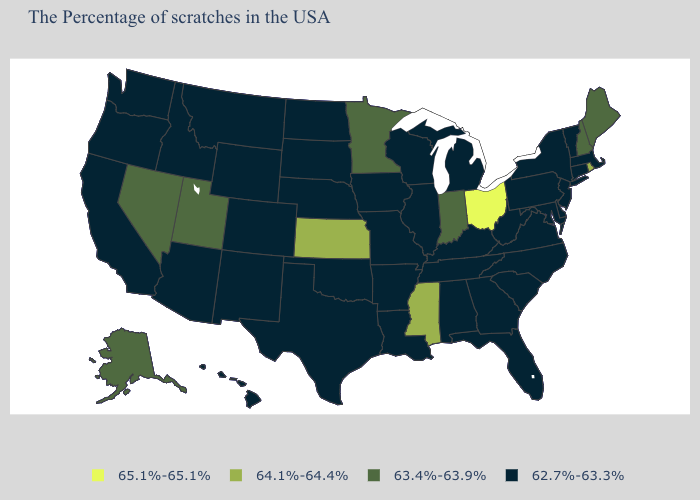Name the states that have a value in the range 64.1%-64.4%?
Give a very brief answer. Rhode Island, Mississippi, Kansas. What is the value of Minnesota?
Quick response, please. 63.4%-63.9%. What is the value of New Jersey?
Keep it brief. 62.7%-63.3%. What is the highest value in states that border Wisconsin?
Short answer required. 63.4%-63.9%. Name the states that have a value in the range 64.1%-64.4%?
Give a very brief answer. Rhode Island, Mississippi, Kansas. Name the states that have a value in the range 63.4%-63.9%?
Keep it brief. Maine, New Hampshire, Indiana, Minnesota, Utah, Nevada, Alaska. What is the value of Nebraska?
Concise answer only. 62.7%-63.3%. What is the value of South Carolina?
Quick response, please. 62.7%-63.3%. What is the value of Minnesota?
Quick response, please. 63.4%-63.9%. Does Georgia have the highest value in the USA?
Short answer required. No. Does Nebraska have the highest value in the USA?
Keep it brief. No. Among the states that border Ohio , does Indiana have the highest value?
Write a very short answer. Yes. Which states hav the highest value in the MidWest?
Quick response, please. Ohio. Among the states that border Texas , which have the highest value?
Be succinct. Louisiana, Arkansas, Oklahoma, New Mexico. Which states hav the highest value in the Northeast?
Write a very short answer. Rhode Island. 